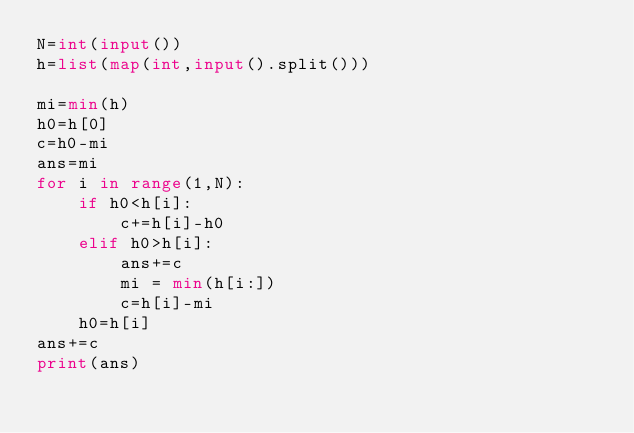Convert code to text. <code><loc_0><loc_0><loc_500><loc_500><_Python_>N=int(input())
h=list(map(int,input().split()))

mi=min(h)
h0=h[0]
c=h0-mi
ans=mi
for i in range(1,N):
    if h0<h[i]:
        c+=h[i]-h0
    elif h0>h[i]:
        ans+=c
        mi = min(h[i:])
        c=h[i]-mi
    h0=h[i]
ans+=c
print(ans)
</code> 